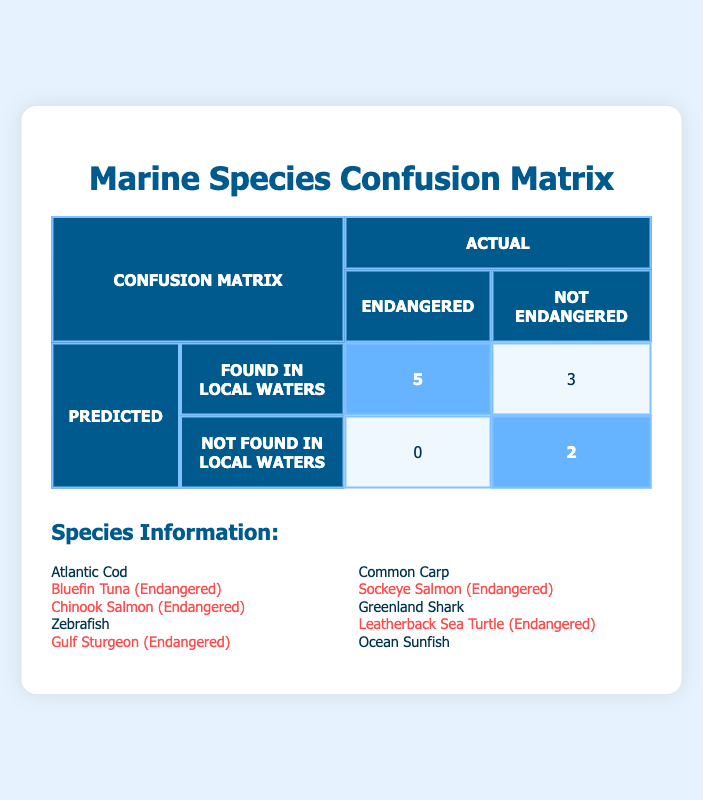What is the number of species found in local waters that are also listed as endangered? In the confusion matrix, under the "Predicted" row for "Found in Local Waters" and "Endangered" in the "Actual" column, the value is 5. This means there are five species that are both found in local waters and are classified as endangered.
Answer: 5 How many species are there in total that are not found in local waters? To find this, we look at the "Not Found in Local Waters" row in the confusion matrix. There are a total of 2 species listed in that row under "Not Endangered," indicating there are two species that are not found in local waters.
Answer: 2 Is the Atlantic Cod classified as an endangered species? Checking the species information in the table, Atlantic Cod is listed as not endangered. Therefore, the statement is false.
Answer: No What is the total number of species classified as endangered? Based on the species information list, we count the endangered species: Bluefin Tuna, Chinook Salmon, Gulf Sturgeon, Sockeye Salmon, and Leatherback Sea Turtle, which totals to 5 endangered species in the local waters context.
Answer: 5 How many more species found in local waters are not endangered compared to those that are endangered? From the matrix, there are 3 species found in local waters that are not endangered (Common Carp and Ocean Sunfish), and 5 species that are endangered. The difference is calculated as 3 (not endangered) - 5 (endangered) = -2. The negative result indicates there are 2 more endangered species.
Answer: 2 more endangered species Does the confusion matrix indicate that any species not found in local waters are endangered? In the matrix, the "Not Found in Local Waters" row shows 0 species classified as endangered, indicating that no species that are not found in local waters are listed as endangered. Therefore, the statement is true.
Answer: No What percentage of species found in local waters are classified as endangered? There are a total of 8 species found in local waters (5 endangered and 3 not endangered). To find the percentage of endangered species, we calculate (5/8) * 100, which gives 62.5%. This means 62.5% of the species found in local waters are classified as endangered.
Answer: 62.5% How many species found in local waters are there compared to the total number classified in the species list? From the species information, there are a total of 10 species listed. From the confusion matrix, 8 species are found in local waters. The percentage is calculated as (8/10) * 100 = 80%. This indicates that 80% of the species listed are found in local waters.
Answer: 80% What is the total count of species in the list that are not found in local waters? In the species list, only 2 species (Zebrafish and Greenland Shark) are not found in local waters. That gives us a total count of 2.
Answer: 2 